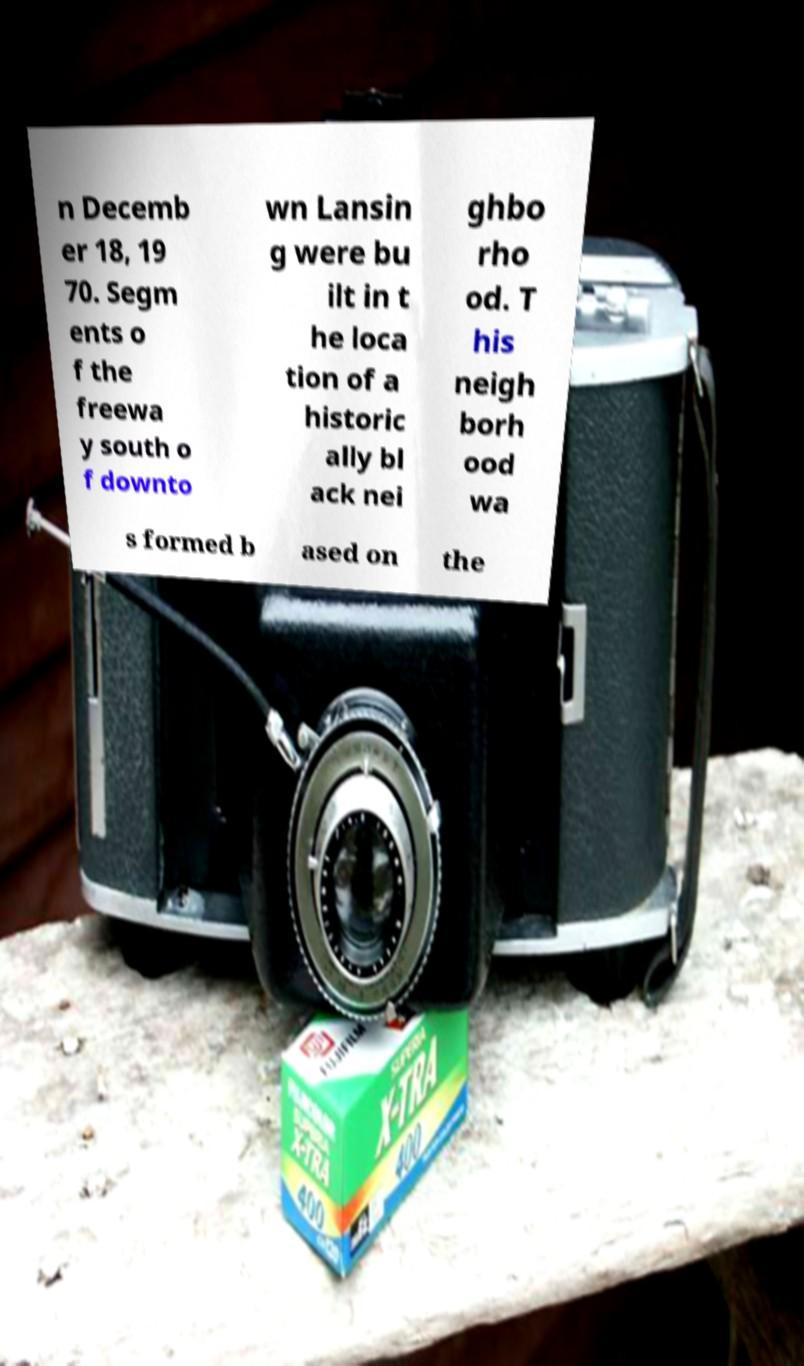Could you assist in decoding the text presented in this image and type it out clearly? n Decemb er 18, 19 70. Segm ents o f the freewa y south o f downto wn Lansin g were bu ilt in t he loca tion of a historic ally bl ack nei ghbo rho od. T his neigh borh ood wa s formed b ased on the 